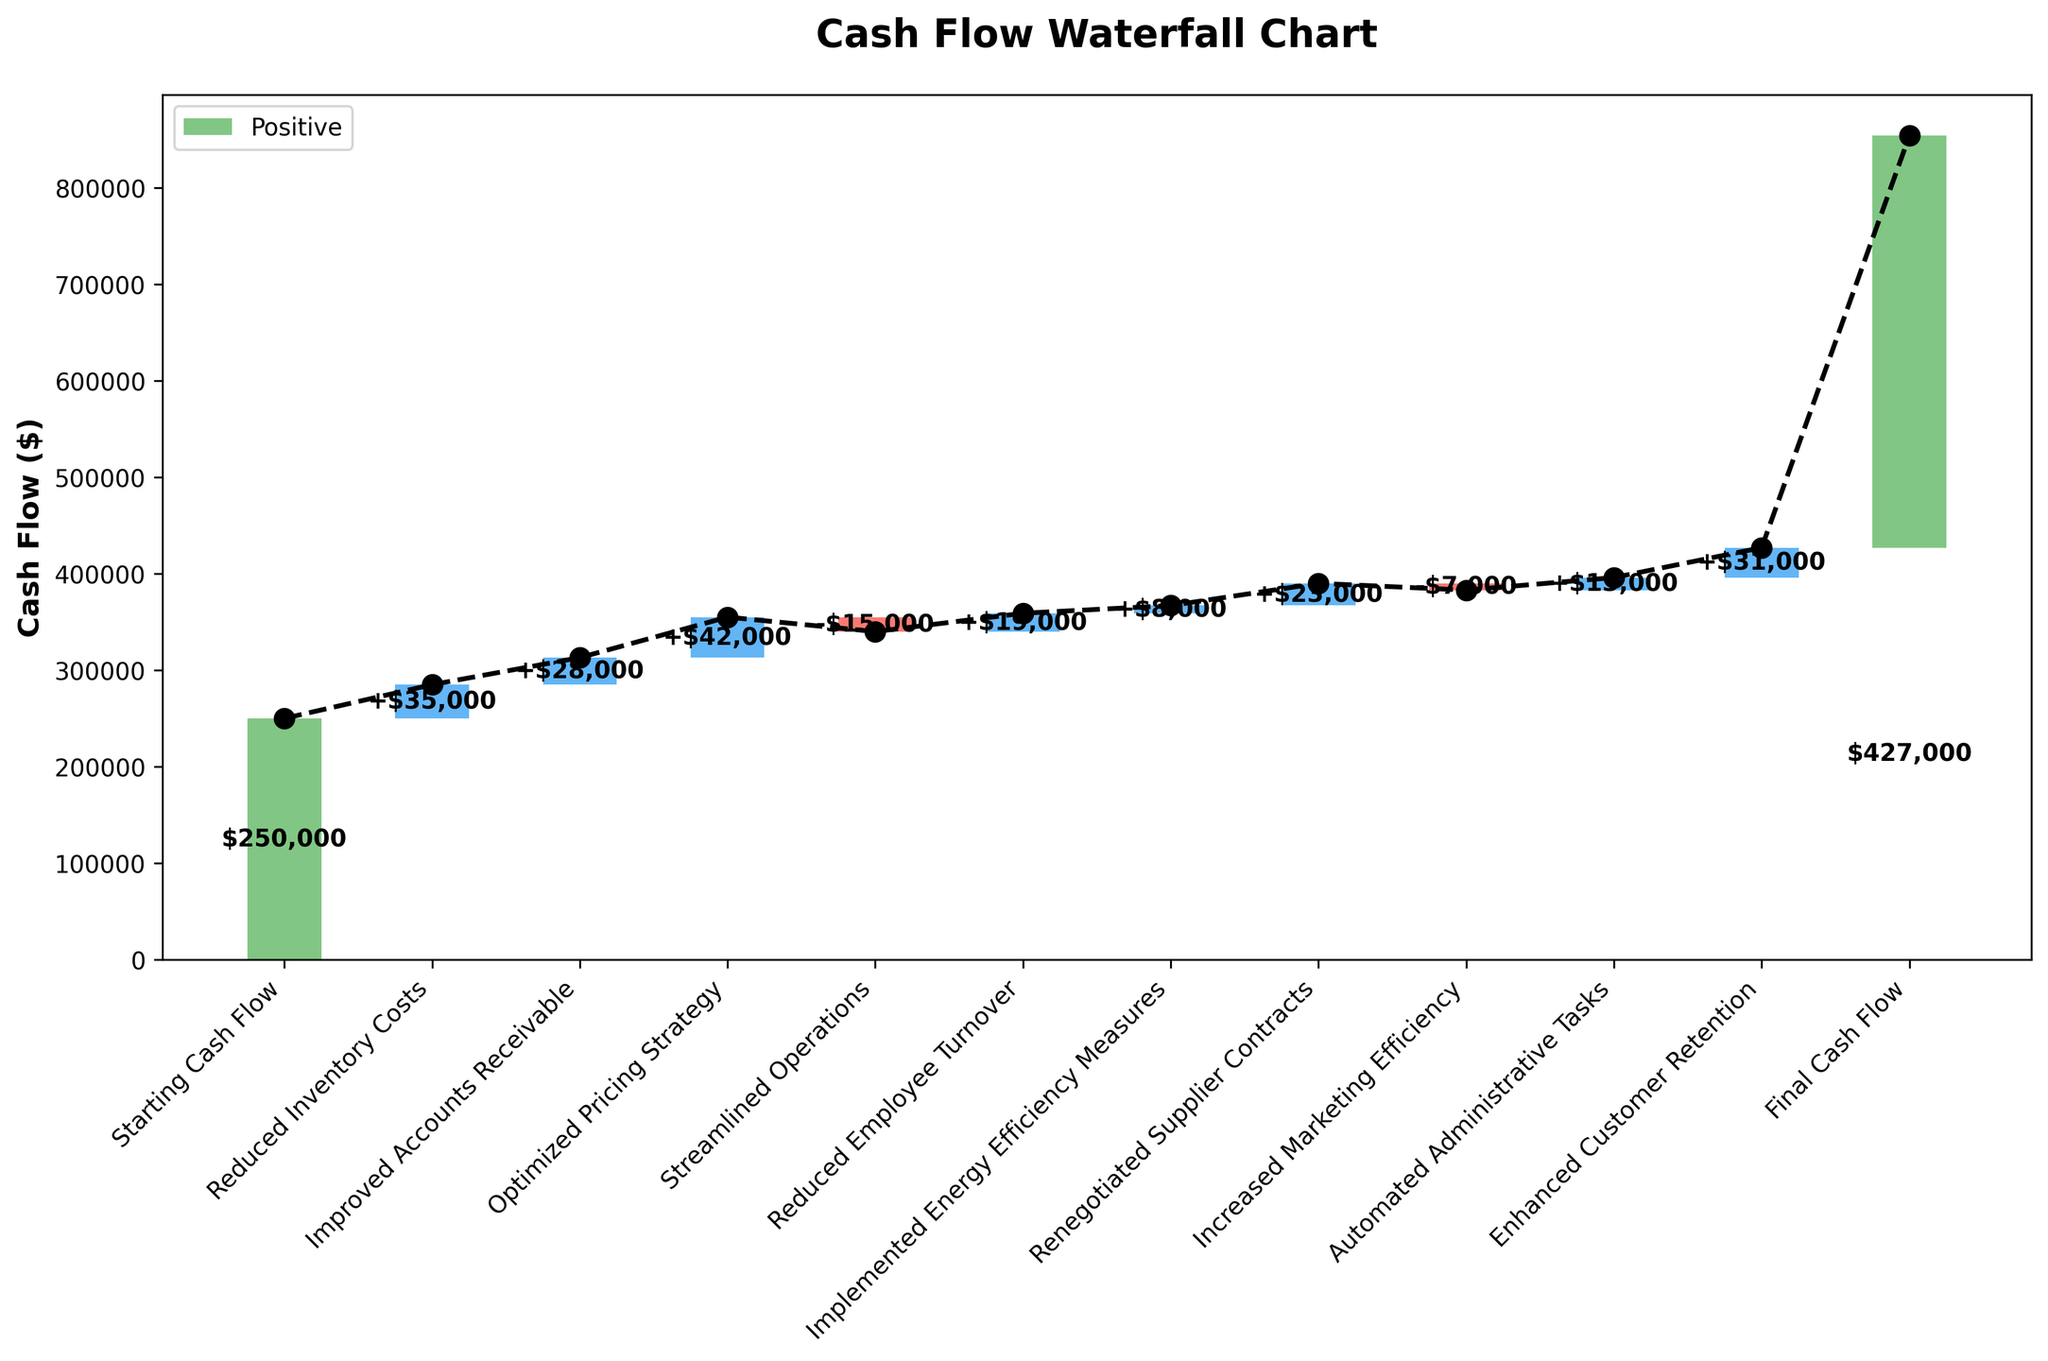what is the title of the chart? The title of the chart is located at the top-center and helps in understanding the main focus of the visualization. In this case, the title is "Cash Flow Waterfall Chart".
Answer: Cash Flow Waterfall Chart what is the final cash flow amount shown in the chart? The final cash flow amount is indicated at the end of the sequence and is labeled accordingly near the last bar. It is shown as $427,000.
Answer: $427,000 which category contributed the most positively to the cash flow? To identify the category that contributed the most positively, look for the tallest blue bar representing a positive cash flow increment. The "Optimized Pricing Strategy" contributed the most positively with a value of $42,000.
Answer: Optimized Pricing Strategy how many categories led to a negative change in cash flow? Negative changes in cash flow are represented by red bars. By counting the red bars, we see that there are two categories: "Streamlined Operations" and "Increased Marketing Efficiency".
Answer: 2 what is the change in cash flow due to "Reduced Inventory Costs" and "Improved Accounts Receivable" combined? Add the values of both categories: Reduced Inventory Costs ($35,000) and Improved Accounts Receivable ($28,000). $35,000 + $28,000 = $63,000.
Answer: $63,000 which categories have negative impacts on cash flow and what is their total combined value? Identify the negative impacting categories (red bars) and sum their values: Streamlined Operations (-$15,000) and Increased Marketing Efficiency (-$7,000). The combined value is -$15,000 + (-$7,000) = -$22,000.
Answer: -$22,000 what is the net change in cash flow from start to end? The net change is calculated by subtracting the starting cash flow from the final cash flow. Final Cash Flow ($427,000) - Starting Cash Flow ($250,000) = $177,000.
Answer: $177,000 which category had a greater contribution to cash flow, "Automated Administrative Tasks" or "Enhanced Customer Retention"? Compare the values of the two categories. Automated Administrative Tasks contributed $13,000 while Enhanced Customer Retention contributed $31,000. Enhanced Customer Retention had a greater contribution.
Answer: Enhanced Customer Retention what is the total increase in cash flow from categories with positive changes? Sum the values of all categories with positive changes: Reduced Inventory Costs ($35,000), Improved Accounts Receivable ($28,000), Optimized Pricing Strategy ($42,000), Reduced Employee Turnover ($19,000), Implemented Energy Efficiency Measures ($8,000), Renegotiated Supplier Contracts ($23,000), Automated Administrative Tasks ($13,000), Enhanced Customer Retention ($31,000). Total = $199,000.
Answer: $199,000 what is the combined impact of "Reduced Employee Turnover" and "Implemented Energy Efficiency Measures" on cash flow? Add the values for both categories: Reduced Employee Turnover ($19,000) and Implemented Energy Efficiency Measures ($8,000). $19,000 + $8,000 = $27,000.
Answer: $27,000 